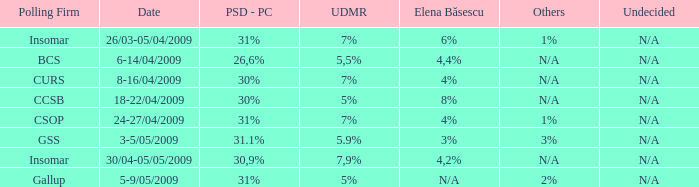What was the udmr for the period 18-22/04/2009? 5%. Could you parse the entire table as a dict? {'header': ['Polling Firm', 'Date', 'PSD - PC', 'UDMR', 'Elena Băsescu', 'Others', 'Undecided'], 'rows': [['Insomar', '26/03-05/04/2009', '31%', '7%', '6%', '1%', 'N/A'], ['BCS', '6-14/04/2009', '26,6%', '5,5%', '4,4%', 'N/A', 'N/A'], ['CURS', '8-16/04/2009', '30%', '7%', '4%', 'N/A', 'N/A'], ['CCSB', '18-22/04/2009', '30%', '5%', '8%', 'N/A', 'N/A'], ['CSOP', '24-27/04/2009', '31%', '7%', '4%', '1%', 'N/A'], ['GSS', '3-5/05/2009', '31.1%', '5.9%', '3%', '3%', 'N/A'], ['Insomar', '30/04-05/05/2009', '30,9%', '7,9%', '4,2%', 'N/A', 'N/A'], ['Gallup', '5-9/05/2009', '31%', '5%', 'N/A', '2%', 'N/A']]} 